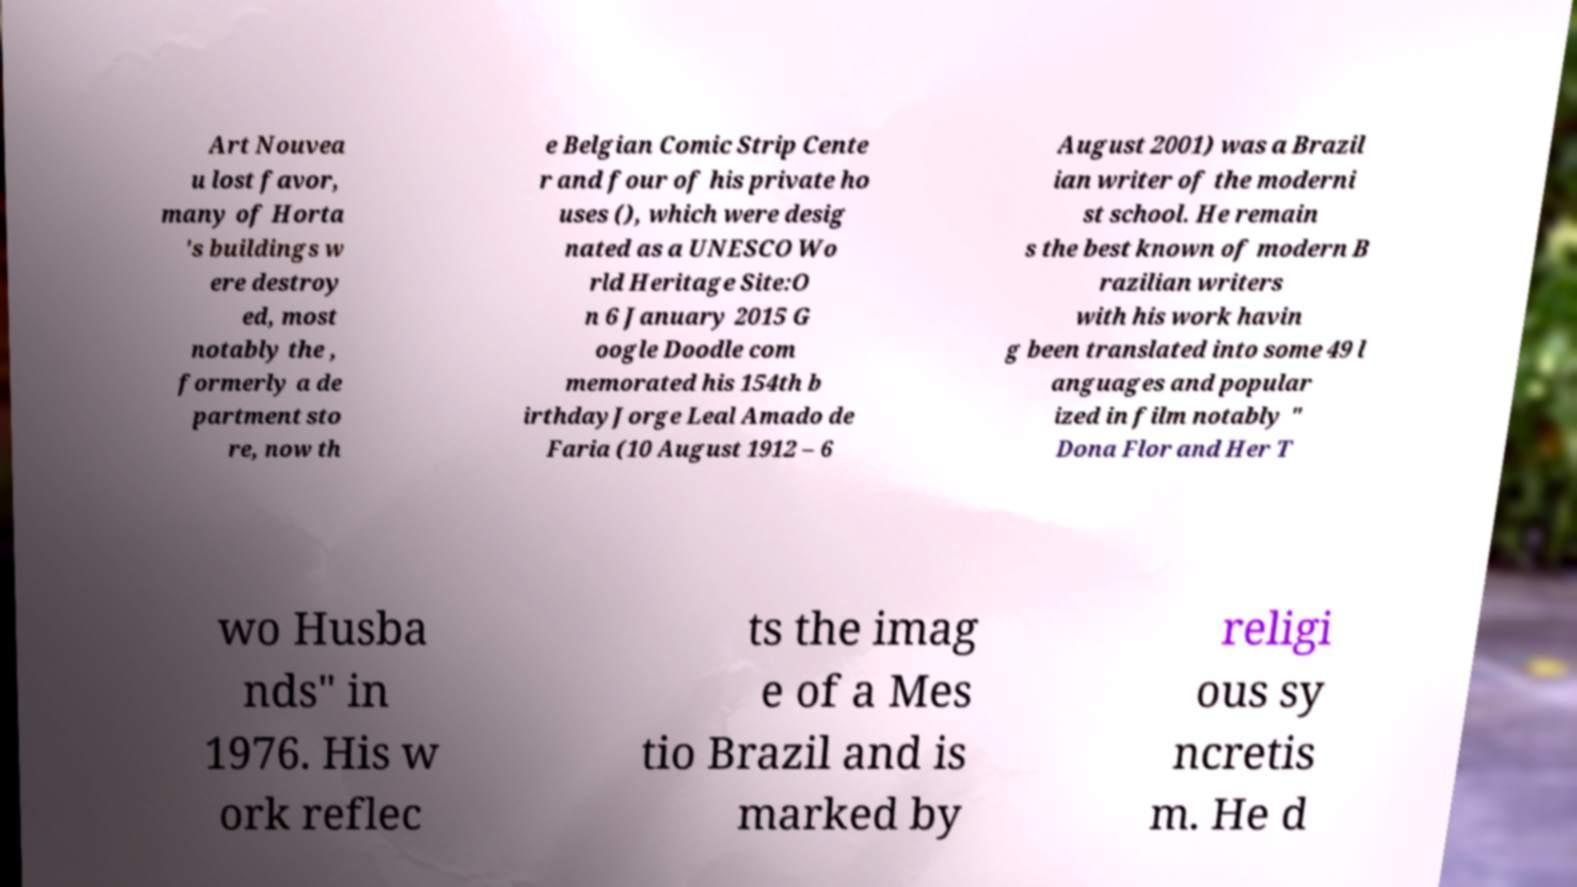Can you accurately transcribe the text from the provided image for me? Art Nouvea u lost favor, many of Horta 's buildings w ere destroy ed, most notably the , formerly a de partment sto re, now th e Belgian Comic Strip Cente r and four of his private ho uses (), which were desig nated as a UNESCO Wo rld Heritage Site:O n 6 January 2015 G oogle Doodle com memorated his 154th b irthdayJorge Leal Amado de Faria (10 August 1912 – 6 August 2001) was a Brazil ian writer of the moderni st school. He remain s the best known of modern B razilian writers with his work havin g been translated into some 49 l anguages and popular ized in film notably " Dona Flor and Her T wo Husba nds" in 1976. His w ork reflec ts the imag e of a Mes tio Brazil and is marked by religi ous sy ncretis m. He d 